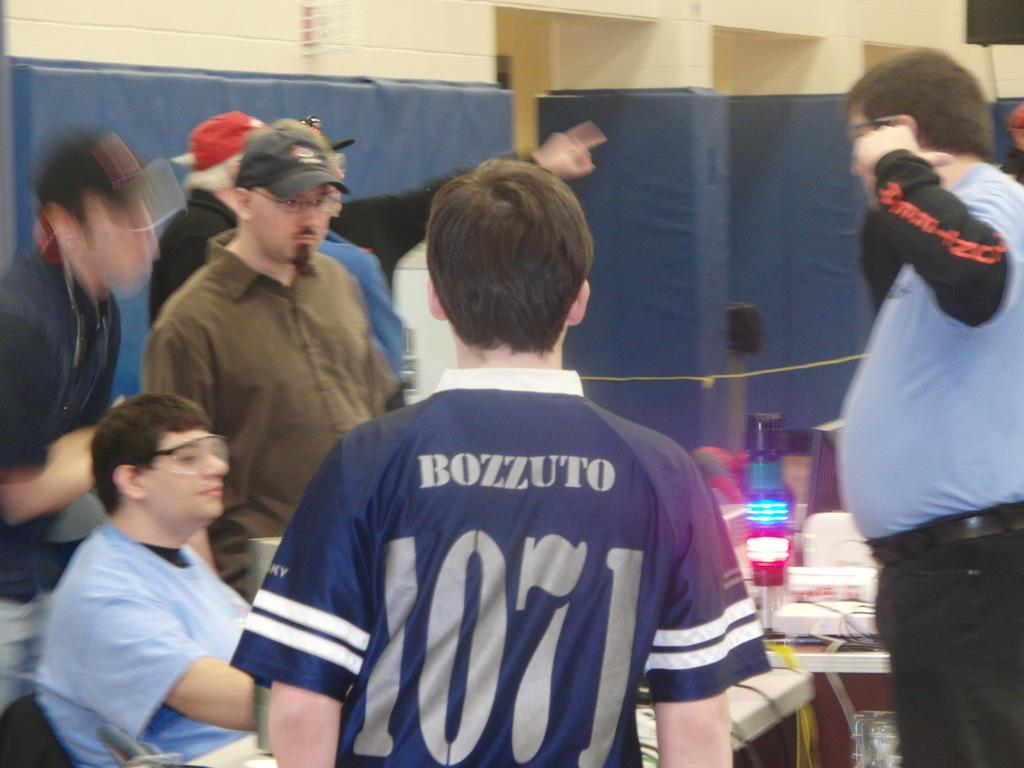Provide a one-sentence caption for the provided image. A group of men are speaking at a table as someone wearing a jersey with the name Bozzuto stands between them. 